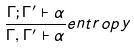Convert formula to latex. <formula><loc_0><loc_0><loc_500><loc_500>\frac { \Gamma ; \Gamma ^ { \prime } \vdash \alpha } { \Gamma , \Gamma ^ { \prime } \vdash \alpha } e n t r o p y</formula> 